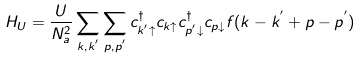<formula> <loc_0><loc_0><loc_500><loc_500>H _ { U } = \frac { U } { N ^ { 2 } _ { a } } \sum _ { k , k ^ { ^ { \prime } } } \sum _ { p , p ^ { ^ { \prime } } } c ^ { \dagger } _ { k ^ { ^ { \prime } } \uparrow } c _ { k \uparrow } c ^ { \dagger } _ { p ^ { ^ { \prime } } \downarrow } c _ { p \downarrow } f ( k - k ^ { ^ { \prime } } + p - p ^ { ^ { \prime } } )</formula> 